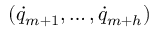Convert formula to latex. <formula><loc_0><loc_0><loc_500><loc_500>( { \dot { q } } _ { m + 1 } , \dots , { \dot { q } } _ { m + h } )</formula> 